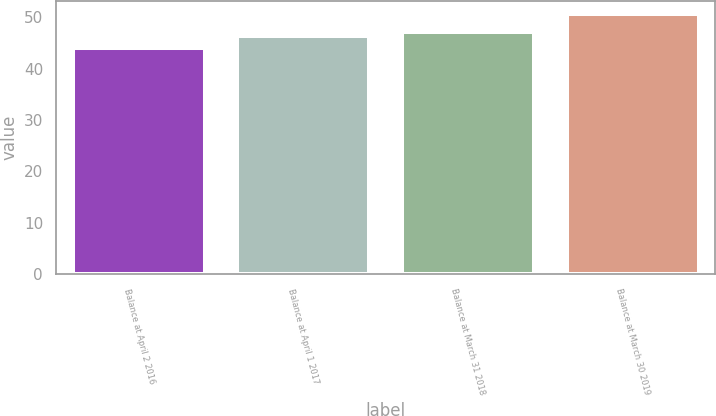Convert chart to OTSL. <chart><loc_0><loc_0><loc_500><loc_500><bar_chart><fcel>Balance at April 2 2016<fcel>Balance at April 1 2017<fcel>Balance at March 31 2018<fcel>Balance at March 30 2019<nl><fcel>44<fcel>46.4<fcel>47.07<fcel>50.7<nl></chart> 